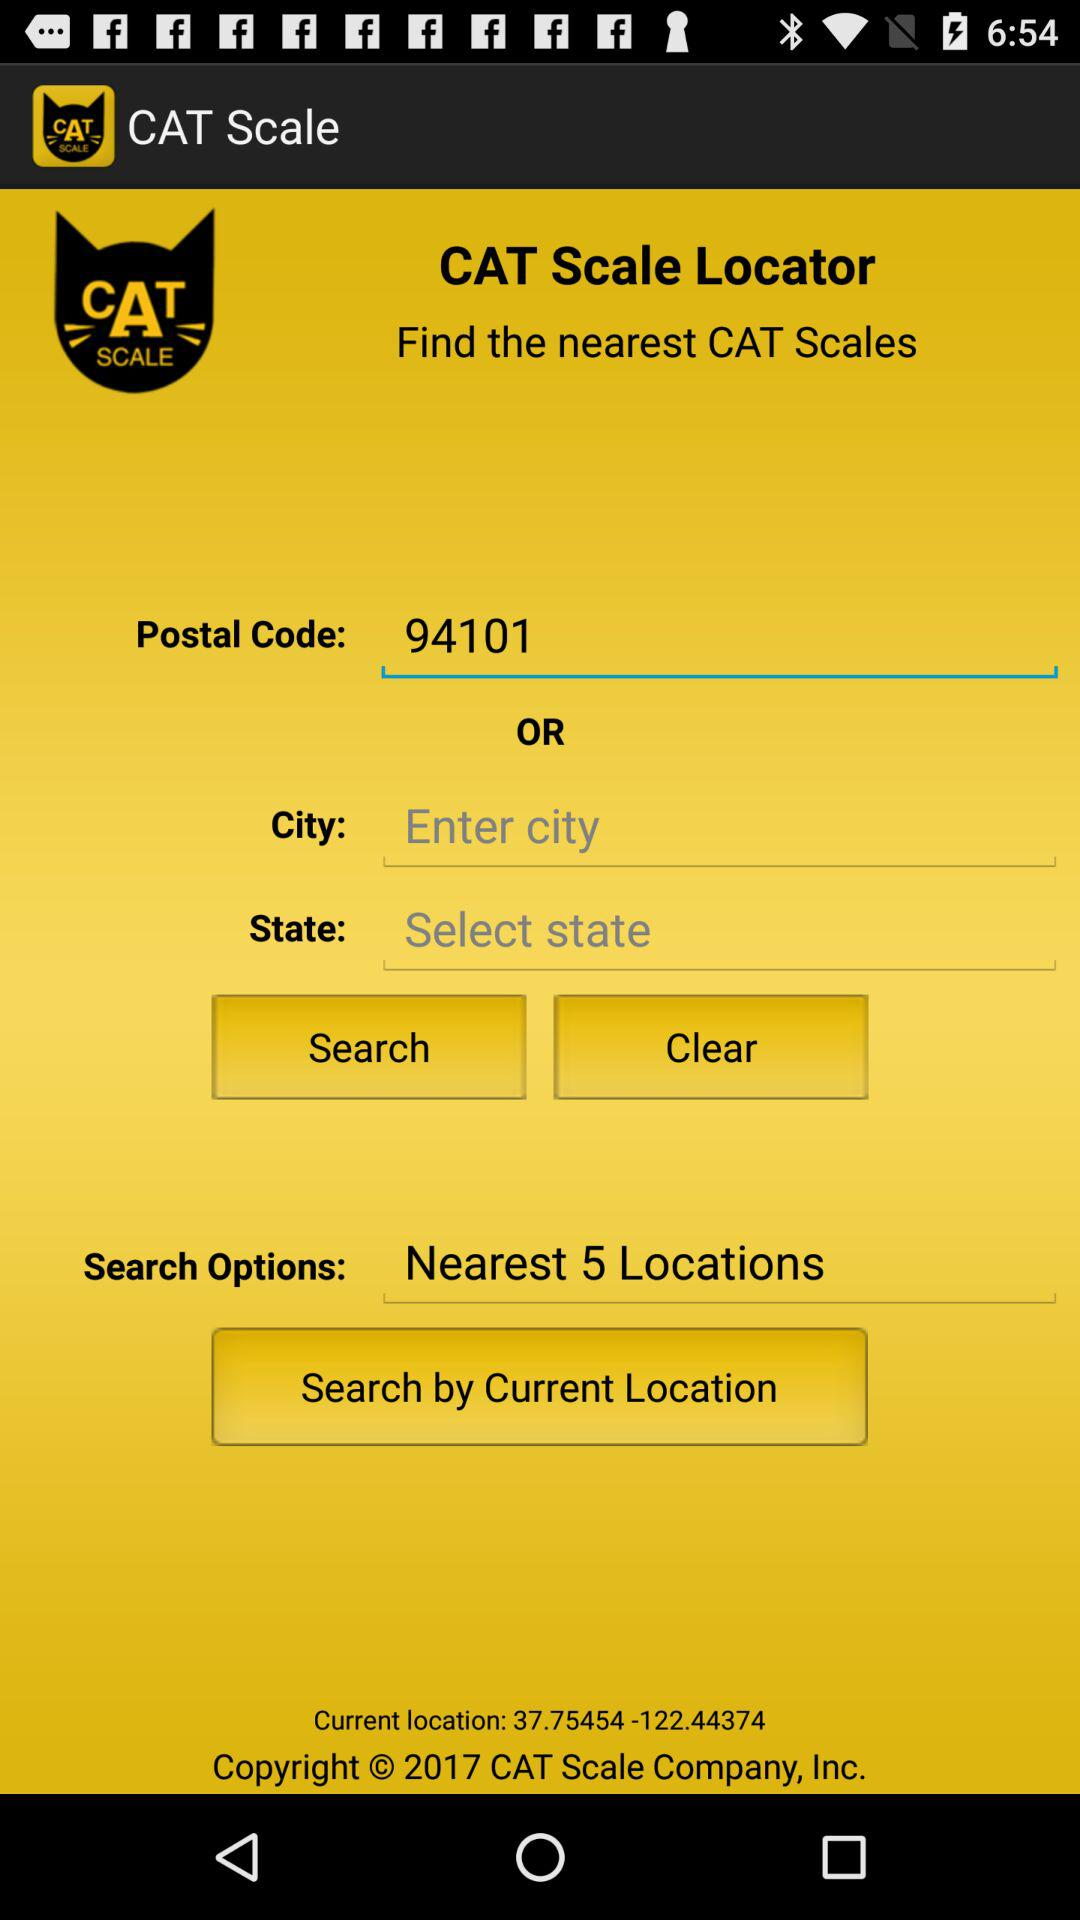What is the current location? The current location is 37.75454-122.44374. 